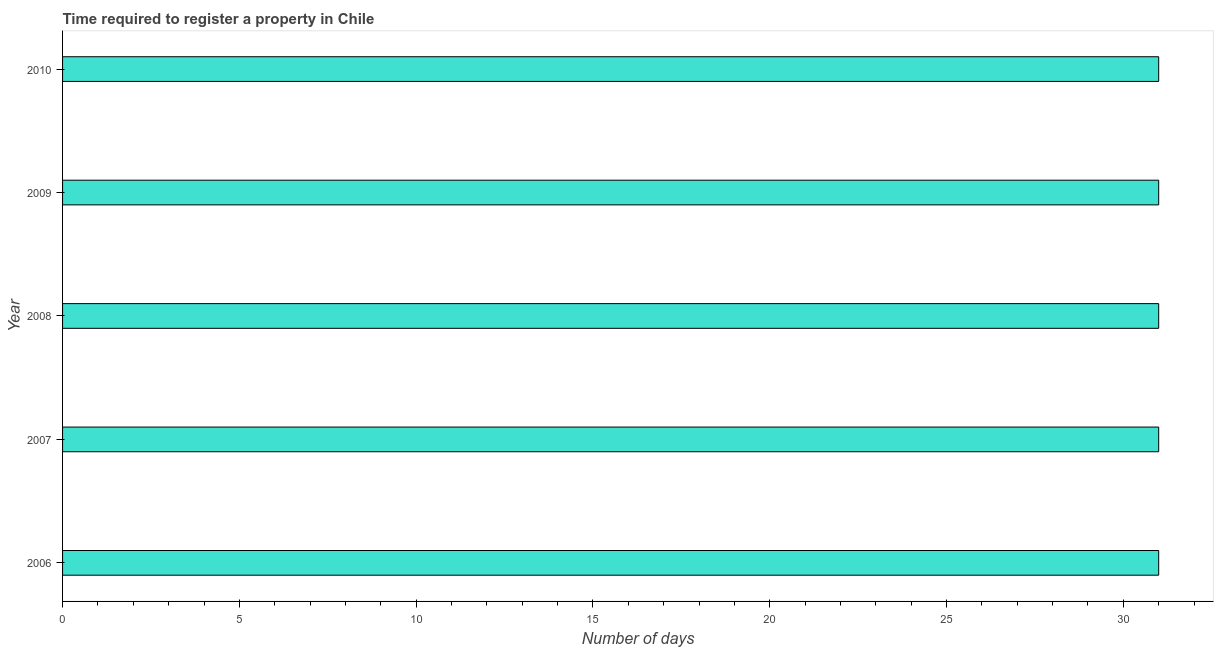What is the title of the graph?
Ensure brevity in your answer.  Time required to register a property in Chile. What is the label or title of the X-axis?
Your answer should be compact. Number of days. What is the label or title of the Y-axis?
Your answer should be compact. Year. What is the number of days required to register property in 2010?
Offer a very short reply. 31. Across all years, what is the minimum number of days required to register property?
Your response must be concise. 31. In which year was the number of days required to register property maximum?
Keep it short and to the point. 2006. In which year was the number of days required to register property minimum?
Provide a succinct answer. 2006. What is the sum of the number of days required to register property?
Offer a terse response. 155. What is the difference between the number of days required to register property in 2006 and 2010?
Offer a terse response. 0. What is the average number of days required to register property per year?
Keep it short and to the point. 31. Do a majority of the years between 2006 and 2010 (inclusive) have number of days required to register property greater than 6 days?
Offer a terse response. Yes. What is the difference between the highest and the lowest number of days required to register property?
Give a very brief answer. 0. How many bars are there?
Offer a very short reply. 5. How many years are there in the graph?
Give a very brief answer. 5. What is the difference between two consecutive major ticks on the X-axis?
Provide a short and direct response. 5. Are the values on the major ticks of X-axis written in scientific E-notation?
Give a very brief answer. No. What is the Number of days in 2006?
Keep it short and to the point. 31. What is the Number of days in 2008?
Offer a very short reply. 31. What is the Number of days in 2010?
Make the answer very short. 31. What is the difference between the Number of days in 2006 and 2009?
Offer a terse response. 0. What is the difference between the Number of days in 2007 and 2008?
Ensure brevity in your answer.  0. What is the difference between the Number of days in 2007 and 2009?
Your answer should be compact. 0. What is the difference between the Number of days in 2007 and 2010?
Your answer should be compact. 0. What is the difference between the Number of days in 2008 and 2009?
Your answer should be compact. 0. What is the difference between the Number of days in 2008 and 2010?
Provide a succinct answer. 0. What is the difference between the Number of days in 2009 and 2010?
Keep it short and to the point. 0. What is the ratio of the Number of days in 2006 to that in 2008?
Ensure brevity in your answer.  1. What is the ratio of the Number of days in 2006 to that in 2009?
Give a very brief answer. 1. What is the ratio of the Number of days in 2007 to that in 2010?
Your response must be concise. 1. 